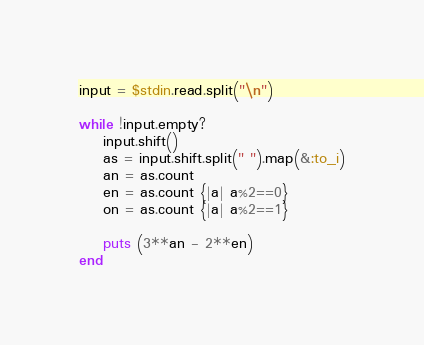<code> <loc_0><loc_0><loc_500><loc_500><_Ruby_>input = $stdin.read.split("\n")

while !input.empty?
	input.shift()
	as = input.shift.split(" ").map(&:to_i)
	an = as.count
	en = as.count {|a| a%2==0}
	on = as.count {|a| a%2==1}

	puts (3**an - 2**en)
end

</code> 